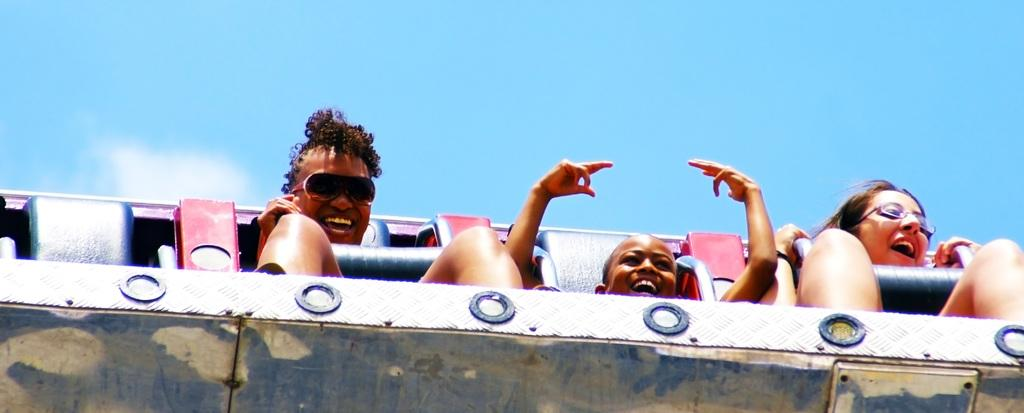How many people are in the image? There are three people in the image. What are the people doing in the image? The people are sitting on a ride. Can you describe the ride in the image? The ride appears to be amazing. What can be seen in the background of the image? There is sky visible in the background of the image. What is the condition of the sky in the image? Clouds are present in the sky. What type of battle is taking place in the image? There is no battle present in the image; it features three people sitting on a ride with a sky background. Can you tell me how many plantations are visible in the image? There are no plantations visible in the image; it features a ride and sky background. 